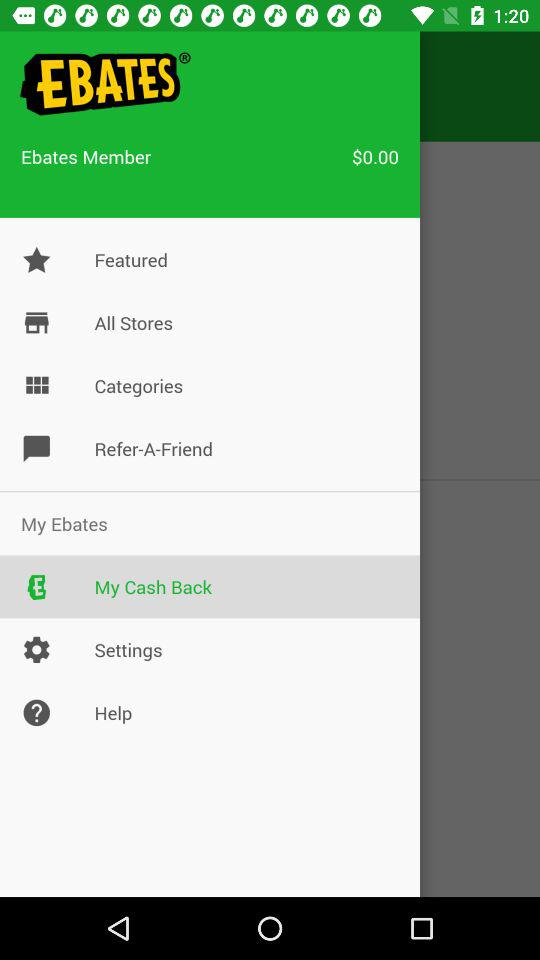How much cash back is available to me?
Answer the question using a single word or phrase. $0.00 